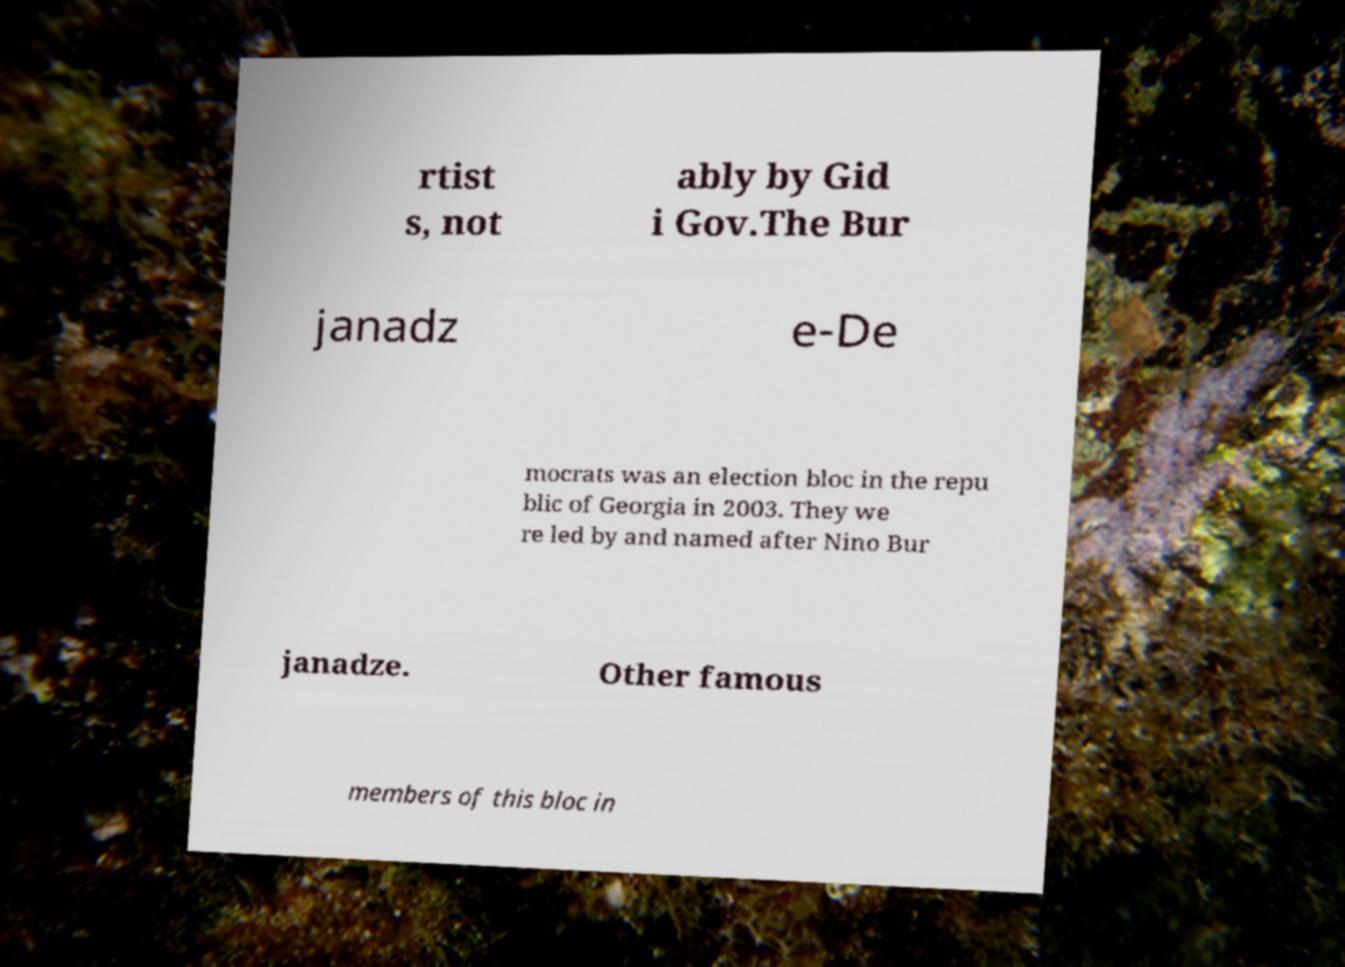For documentation purposes, I need the text within this image transcribed. Could you provide that? rtist s, not ably by Gid i Gov.The Bur janadz e-De mocrats was an election bloc in the repu blic of Georgia in 2003. They we re led by and named after Nino Bur janadze. Other famous members of this bloc in 